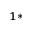<formula> <loc_0><loc_0><loc_500><loc_500>^ { 1 \ast }</formula> 